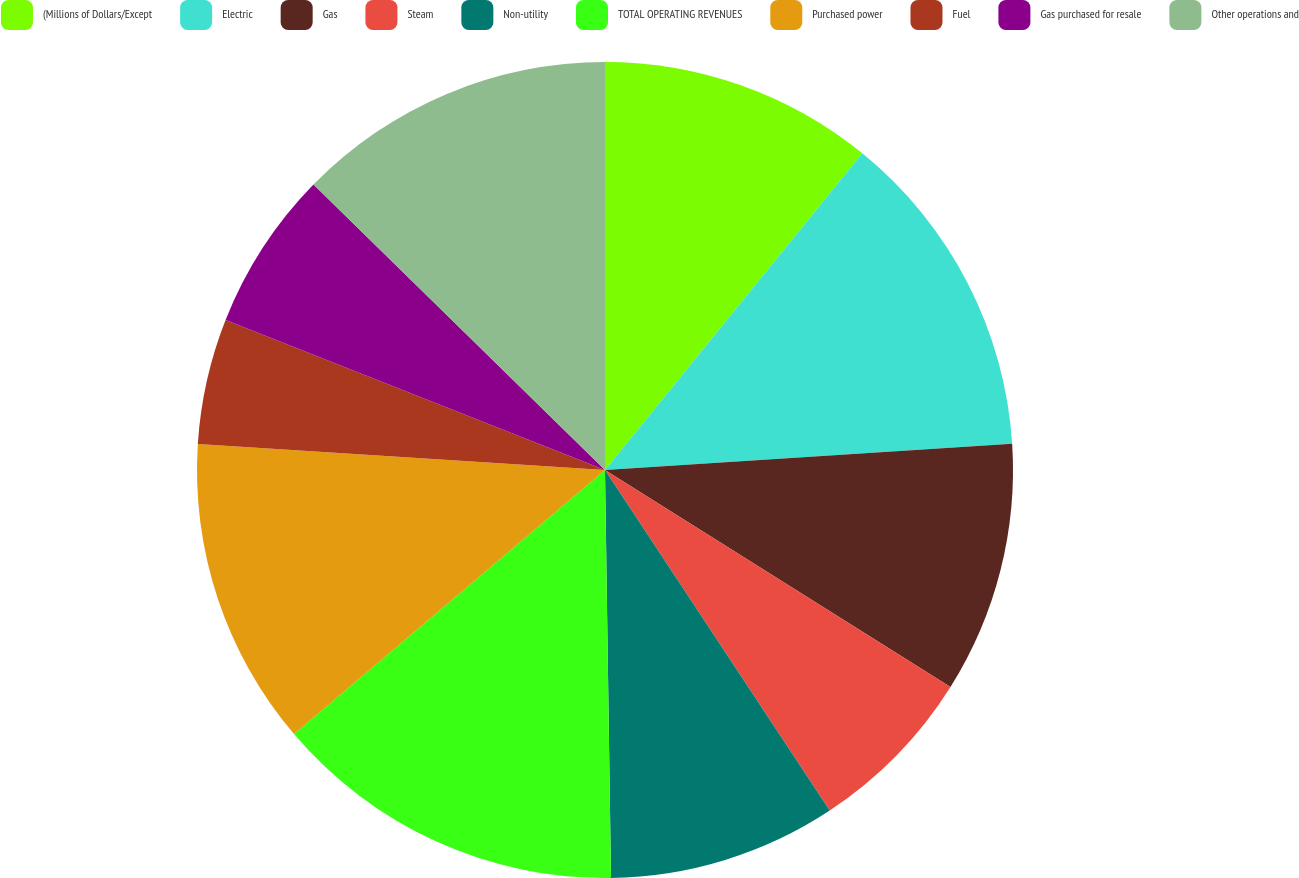Convert chart. <chart><loc_0><loc_0><loc_500><loc_500><pie_chart><fcel>(Millions of Dollars/Except<fcel>Electric<fcel>Gas<fcel>Steam<fcel>Non-utility<fcel>TOTAL OPERATING REVENUES<fcel>Purchased power<fcel>Fuel<fcel>Gas purchased for resale<fcel>Other operations and<nl><fcel>10.86%<fcel>13.12%<fcel>9.95%<fcel>6.79%<fcel>9.05%<fcel>14.03%<fcel>12.22%<fcel>4.98%<fcel>6.34%<fcel>12.67%<nl></chart> 